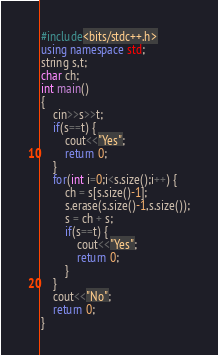<code> <loc_0><loc_0><loc_500><loc_500><_C++_>#include<bits/stdc++.h>
using namespace std;
string s,t;
char ch;
int main()
{
	cin>>s>>t;
	if(s==t) {
		cout<<"Yes";
		return 0;
	}
	for(int i=0;i<s.size();i++) {
		ch = s[s.size()-1];
		s.erase(s.size()-1,s.size());
		s = ch + s;
		if(s==t) {
			cout<<"Yes";
			return 0;
		}
	}
	cout<<"No";
	return 0;
}</code> 